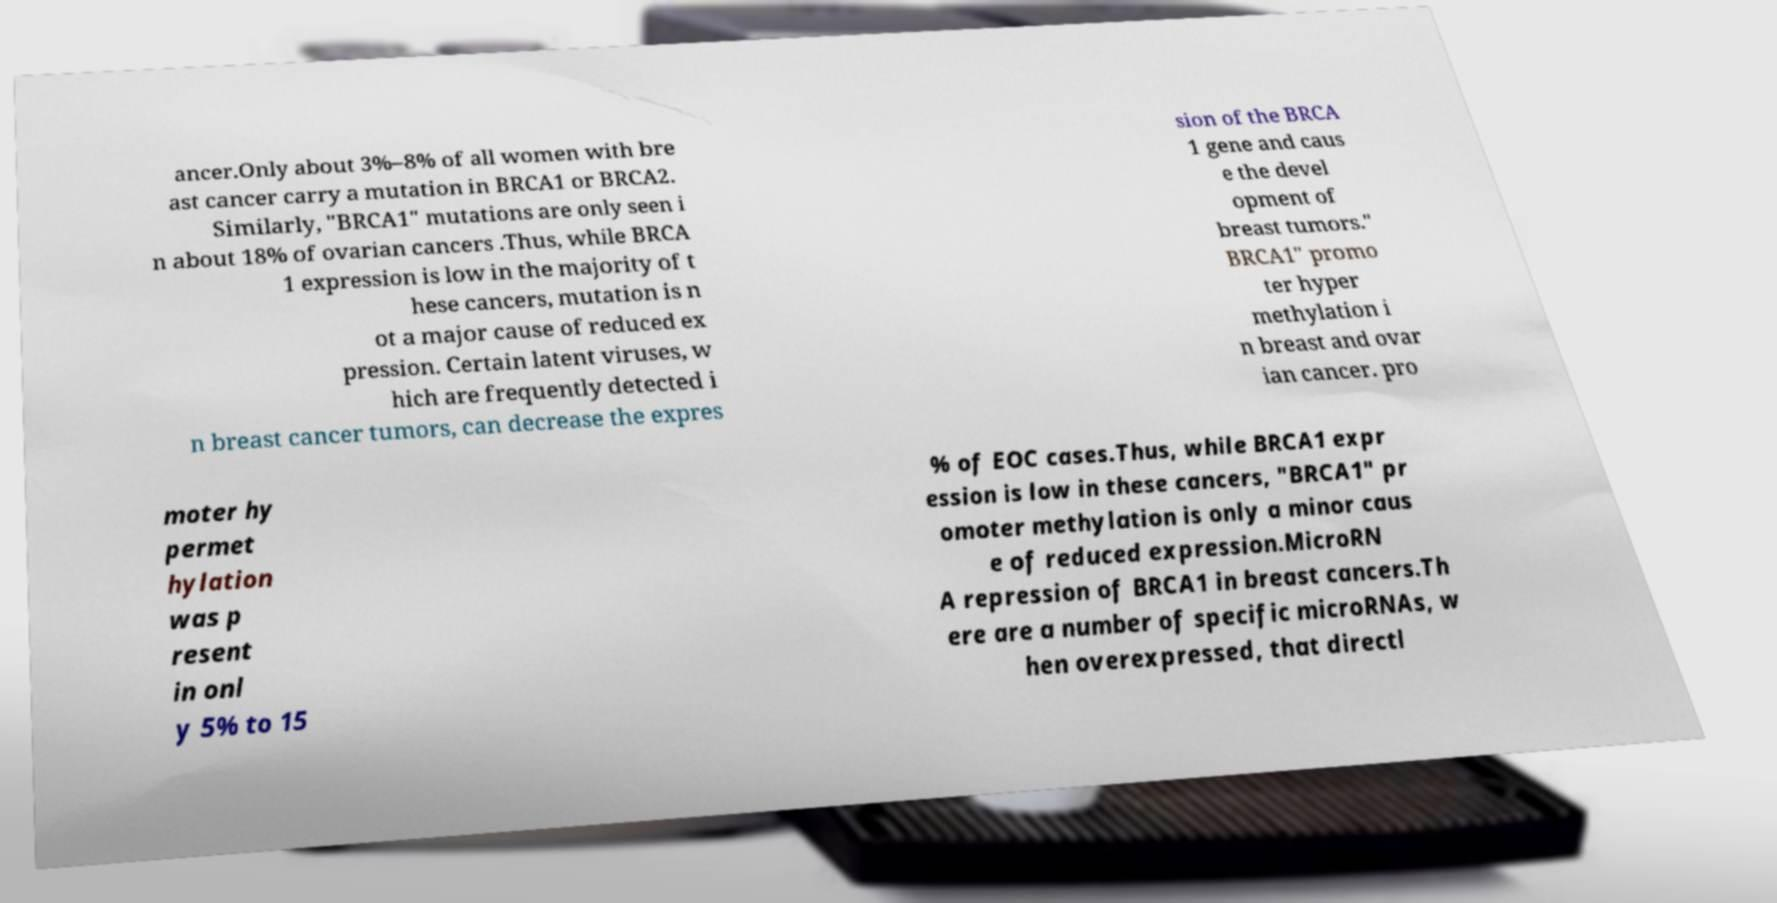Can you read and provide the text displayed in the image?This photo seems to have some interesting text. Can you extract and type it out for me? ancer.Only about 3%–8% of all women with bre ast cancer carry a mutation in BRCA1 or BRCA2. Similarly, "BRCA1" mutations are only seen i n about 18% of ovarian cancers .Thus, while BRCA 1 expression is low in the majority of t hese cancers, mutation is n ot a major cause of reduced ex pression. Certain latent viruses, w hich are frequently detected i n breast cancer tumors, can decrease the expres sion of the BRCA 1 gene and caus e the devel opment of breast tumors." BRCA1" promo ter hyper methylation i n breast and ovar ian cancer. pro moter hy permet hylation was p resent in onl y 5% to 15 % of EOC cases.Thus, while BRCA1 expr ession is low in these cancers, "BRCA1" pr omoter methylation is only a minor caus e of reduced expression.MicroRN A repression of BRCA1 in breast cancers.Th ere are a number of specific microRNAs, w hen overexpressed, that directl 